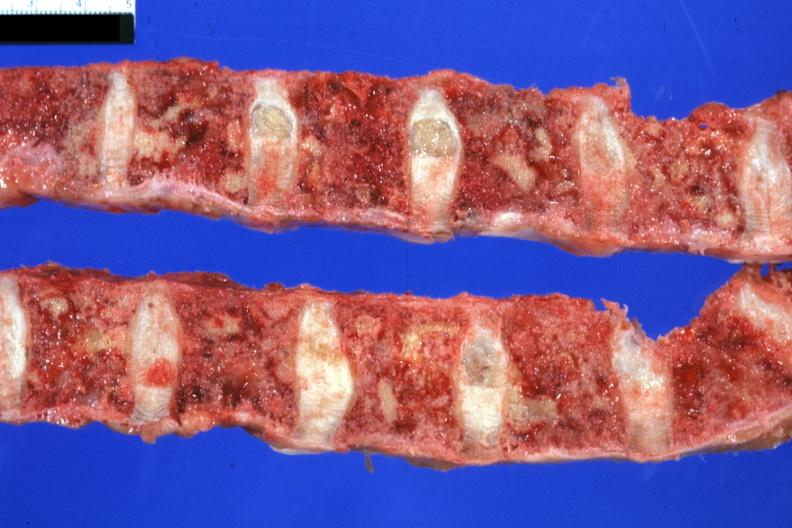how is vertebral column with multiple lesions seen seen colon?
Answer the question using a single word or phrase. Primary 